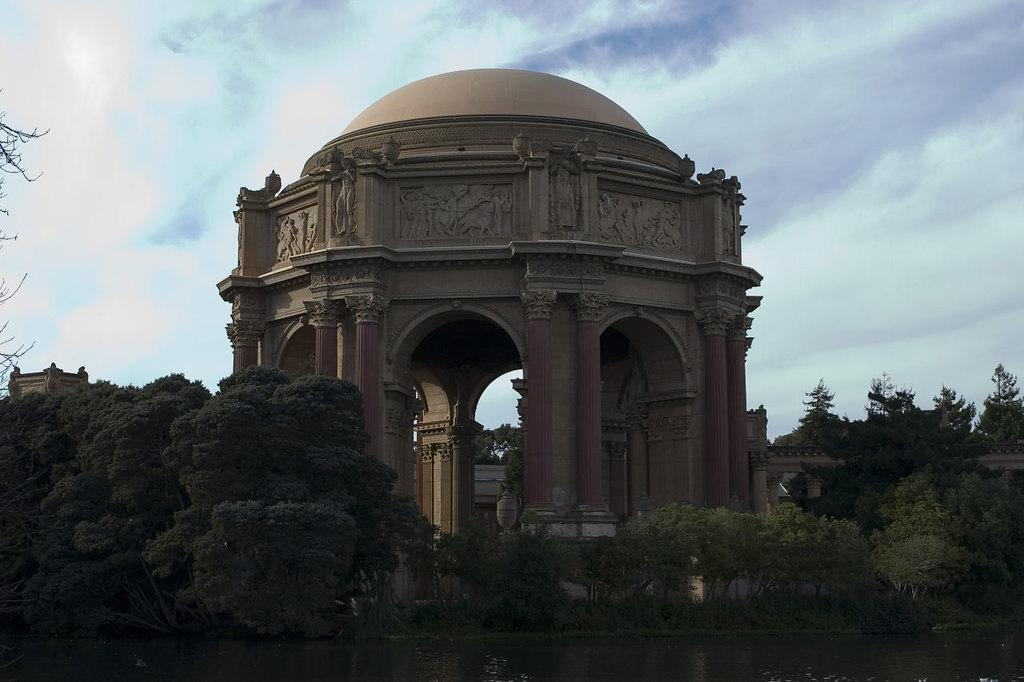What type of structure is depicted in the image? There is a monumental structure with sculptures, pillars, and arches in the image. What can be seen around the structure? There are many trees near the structure. What is at the bottom of the image? There is water at the bottom of the image. What can be seen in the background of the image? The sky with clouds is visible in the background. How many spiders are crawling on the monumental structure in the image? There are no spiders visible on the monumental structure in the image. 